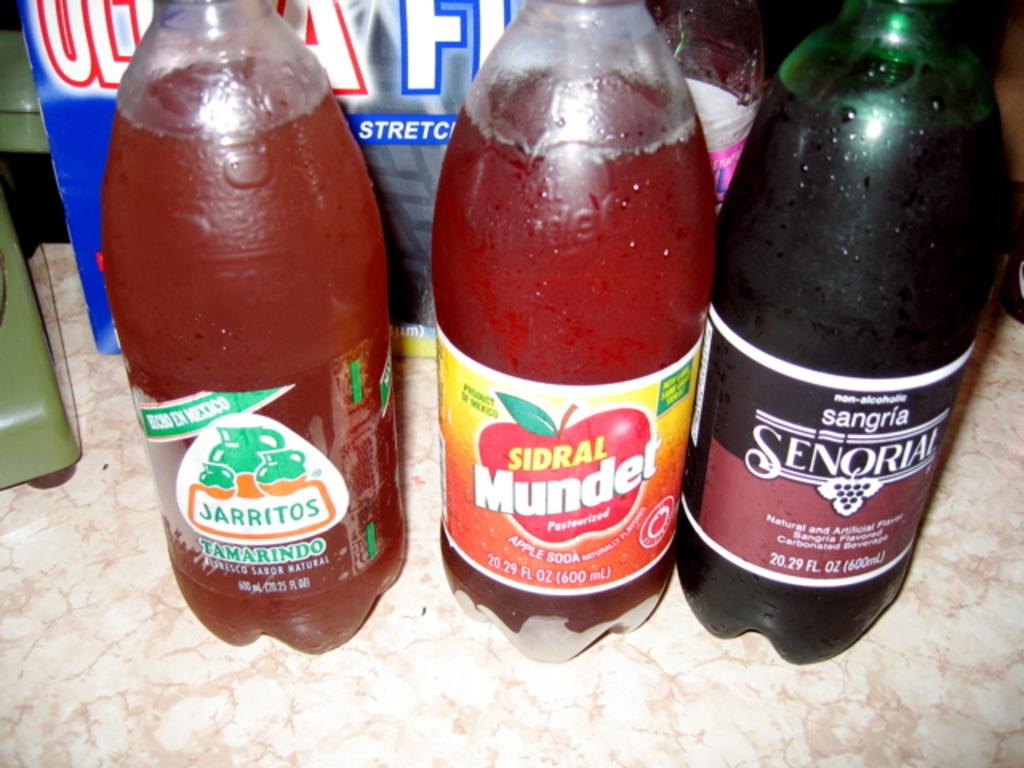<image>
Describe the image concisely. Three bottles of various drinks which are Jarritos, Sidral Munder and Sangria Senqrial. 